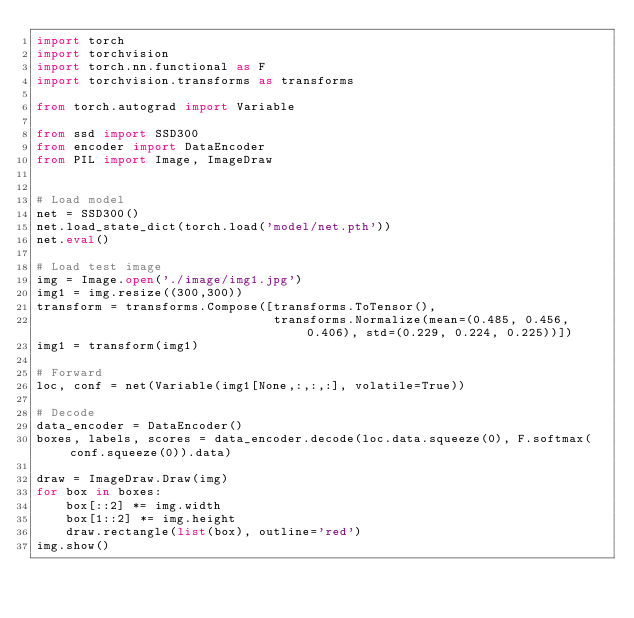<code> <loc_0><loc_0><loc_500><loc_500><_Python_>import torch
import torchvision
import torch.nn.functional as F
import torchvision.transforms as transforms

from torch.autograd import Variable

from ssd import SSD300
from encoder import DataEncoder
from PIL import Image, ImageDraw


# Load model
net = SSD300()
net.load_state_dict(torch.load('model/net.pth'))
net.eval()

# Load test image
img = Image.open('./image/img1.jpg')
img1 = img.resize((300,300))
transform = transforms.Compose([transforms.ToTensor(),
                                transforms.Normalize(mean=(0.485, 0.456, 0.406), std=(0.229, 0.224, 0.225))])
img1 = transform(img1)

# Forward
loc, conf = net(Variable(img1[None,:,:,:], volatile=True))

# Decode
data_encoder = DataEncoder()
boxes, labels, scores = data_encoder.decode(loc.data.squeeze(0), F.softmax(conf.squeeze(0)).data)

draw = ImageDraw.Draw(img)
for box in boxes:
    box[::2] *= img.width
    box[1::2] *= img.height
    draw.rectangle(list(box), outline='red')
img.show()
</code> 